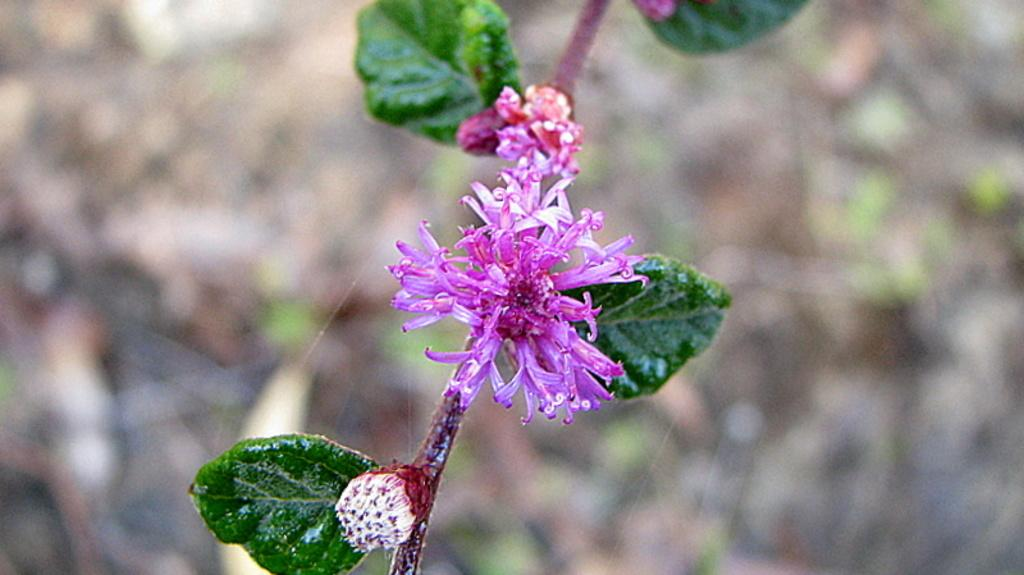What is the main subject of the image? The main subject of the image is a stem with flowers. What features can be observed on the stem? The stem has leaves and a bud. How would you describe the background of the image? The background of the image is blurred. What type of country trail can be seen in the image? There is no country trail present in the image; it features a stem with flowers, leaves, and a bud against a blurred background. 